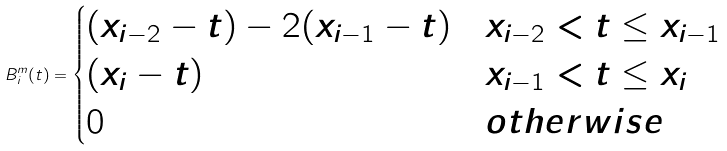Convert formula to latex. <formula><loc_0><loc_0><loc_500><loc_500>B ^ { m } _ { i } ( t ) = \begin{cases} ( x _ { i - 2 } - t ) - 2 ( x _ { i - 1 } - t ) & x _ { i - 2 } < t \leq x _ { i - 1 } \\ ( x _ { i } - t ) & x _ { i - 1 } < t \leq x _ { i } \\ 0 & o t h e r w i s e \\ \end{cases}</formula> 